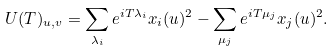<formula> <loc_0><loc_0><loc_500><loc_500>U ( T ) _ { u , v } = \sum _ { \lambda _ { i } } e ^ { i T \lambda _ { i } } x _ { i } ( u ) ^ { 2 } - \sum _ { \mu _ { j } } e ^ { i T \mu _ { j } } x _ { j } ( u ) ^ { 2 } .</formula> 